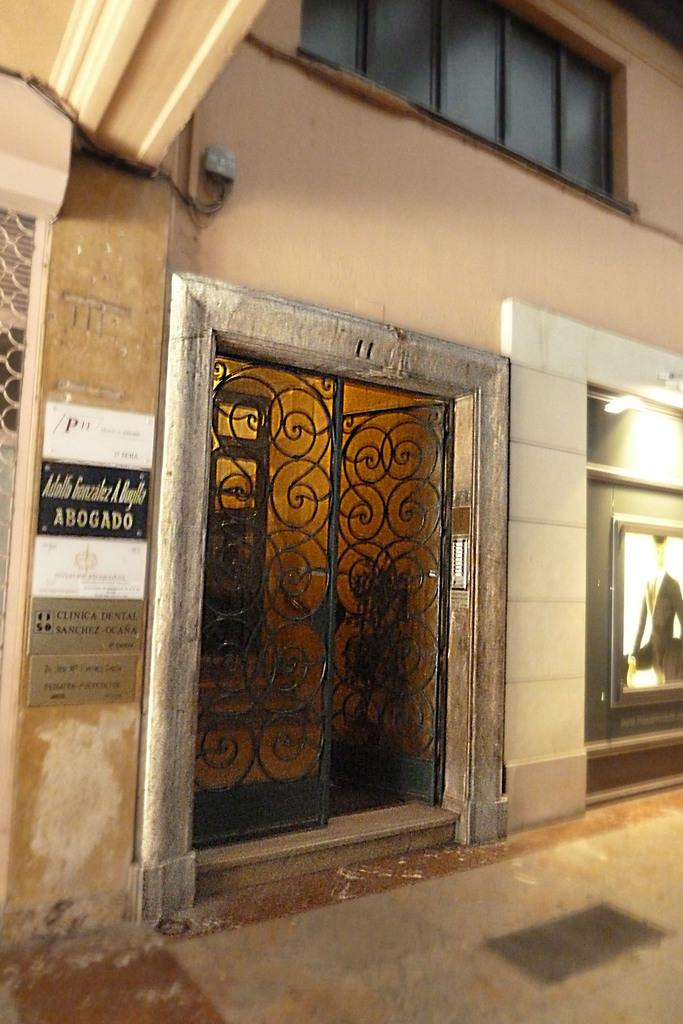What type of structure is present in the image? There is a building in the image. What feature can be seen on the building? The building has a gate. Are there any signs or notices in the image? Yes, there are boards with text in the image. What architectural feature is present in the building for ventilation? There are glasses for ventilation in the building. Can you describe the lighting conditions in the image? There is light visible in the image. Is there a man reading a book inside the cave in the image? There is no cave or man reading a book in the image; it features a building with a gate, boards with text, ventilation glasses, and visible light. 